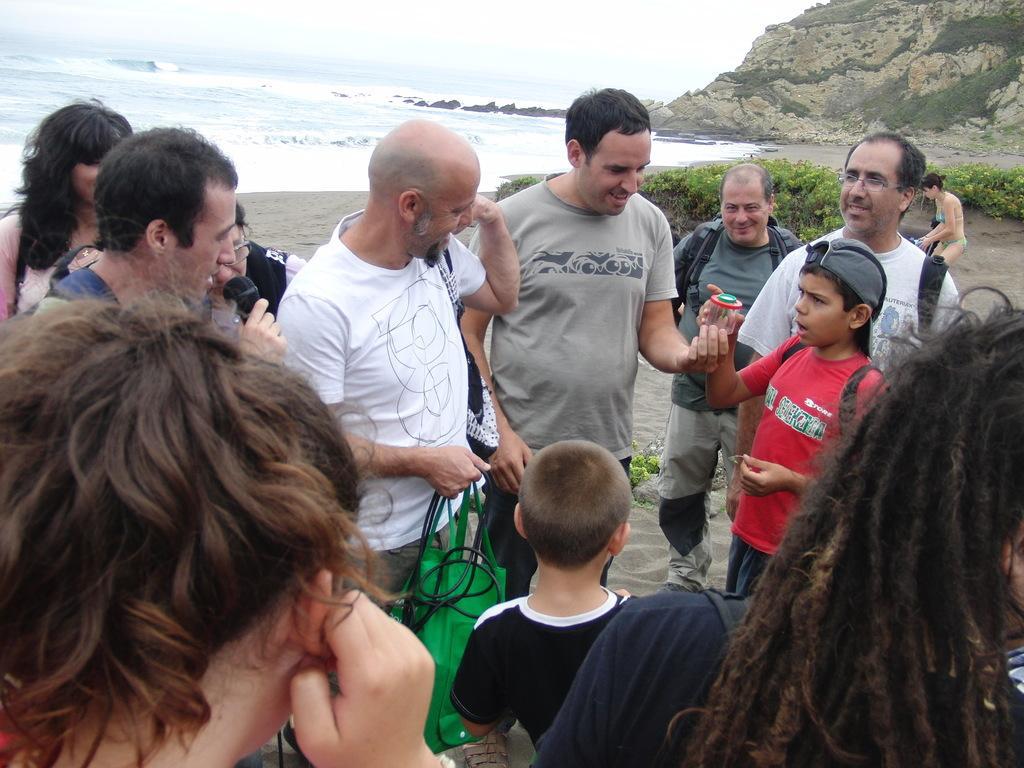Can you describe this image briefly? In this picture I can see in the middle a group of people are standing. On the right side there are plants, on the left there is water. In the top right hand side there is the hill. 